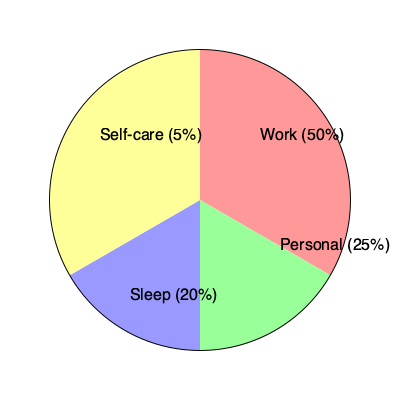Based on the pie chart showing your current time allocation, what percentage of your day should you ideally reallocate to self-care activities to achieve a more balanced lifestyle? To determine the ideal percentage to reallocate to self-care, let's follow these steps:

1. Analyze the current allocation:
   - Work: 50%
   - Personal: 25%
   - Sleep: 20%
   - Self-care: 5%

2. Recognize that self-care is significantly underrepresented at only 5%.

3. Consider a balanced approach:
   - Sleep should remain at 20% (8 hours per day) for health reasons.
   - Work hours could be slightly reduced.
   - Personal time can be maintained or slightly increased.
   - Self-care should be increased significantly.

4. Propose a new allocation:
   - Work: 45% (reduce by 5%)
   - Personal: 25% (maintain)
   - Sleep: 20% (maintain)
   - Self-care: 10% (increase by 5%)

5. Calculate the reallocation:
   Current self-care: 5%
   Ideal self-care: 10%
   Difference: 10% - 5% = 5%

Therefore, you should ideally reallocate 5% of your day to self-care activities.
Answer: 5% 